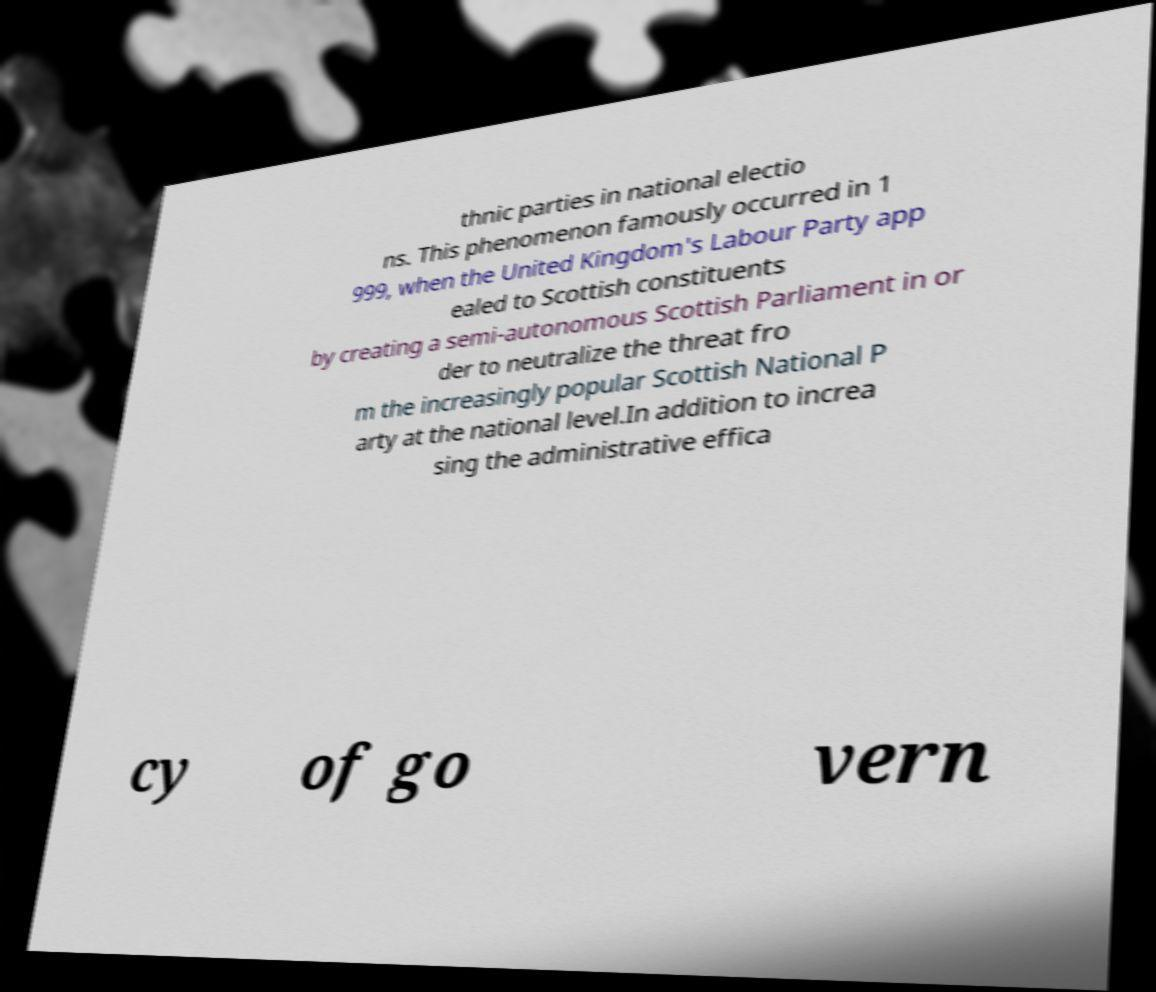There's text embedded in this image that I need extracted. Can you transcribe it verbatim? thnic parties in national electio ns. This phenomenon famously occurred in 1 999, when the United Kingdom's Labour Party app ealed to Scottish constituents by creating a semi-autonomous Scottish Parliament in or der to neutralize the threat fro m the increasingly popular Scottish National P arty at the national level.In addition to increa sing the administrative effica cy of go vern 